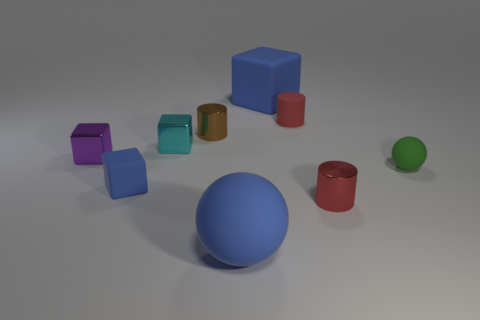Can you infer anything about the texture and size of these objects? Absolutely. The objects display a variety of textures and sizes. The larger blue and red blocks, along with the smaller violet block, have a distinct matte finish, which suggests a non-reflective and possibly soft or textured surface. The cyan-colored metallic block shines with a glossy surface that likely feels smoother to the touch. As for size, the blue ball is the largest object featured, followed by the red block and the blue block. The smaller balls and blocks appear to be of similar yet smaller sizes, fill in details forming a diverse, visually stimulating collection. 